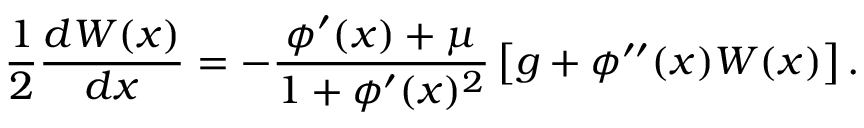<formula> <loc_0><loc_0><loc_500><loc_500>\frac { 1 } { 2 } \frac { d W ( x ) } { d x } = - \frac { \phi ^ { \prime } ( x ) + \mu } { 1 + \phi ^ { \prime } ( x ) ^ { 2 } } \left [ { g + \phi ^ { \prime \prime } ( x ) W ( x ) } \right ] .</formula> 